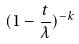Convert formula to latex. <formula><loc_0><loc_0><loc_500><loc_500>( 1 - \frac { t } { \lambda } ) ^ { - k }</formula> 